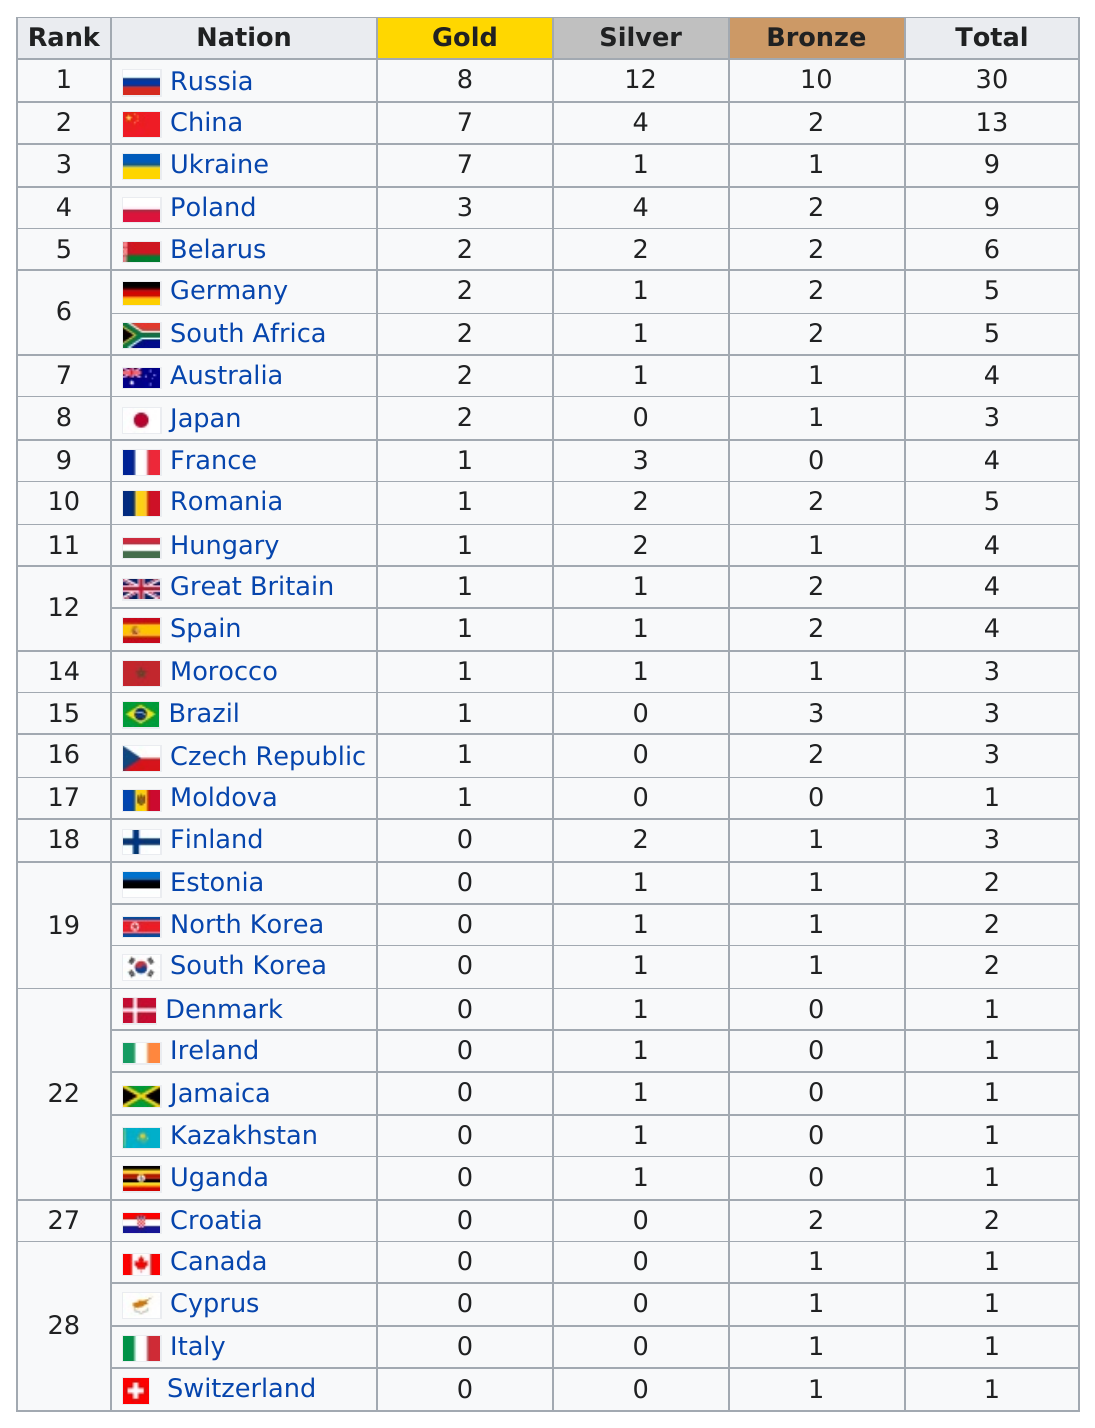List a handful of essential elements in this visual. Out of the total number of countries participating in the Olympics, 14 countries earned no gold medals. The countries listed do not have silver medals. There are 32 nations listed in the table. The nation that leads in the medal count is Russia. Japan is the only country in the top ten that did not earn a silver medal. 